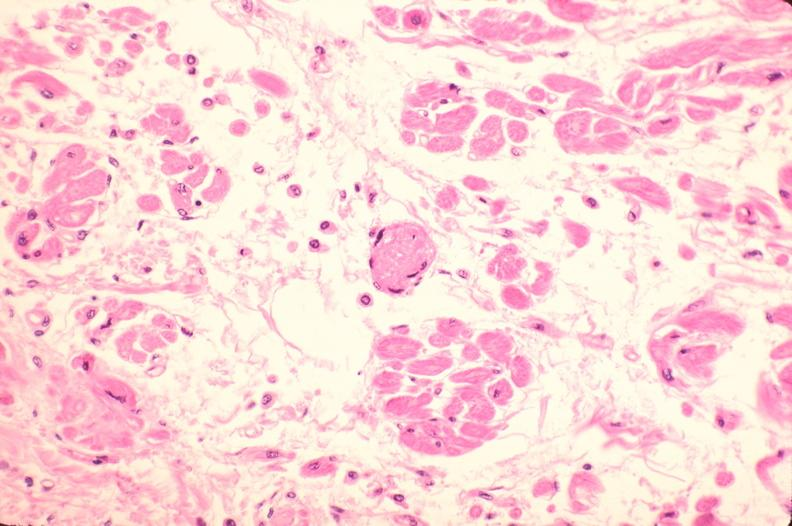does this image show heart, microthrombi, thrombotic thrombocytopenic purpura?
Answer the question using a single word or phrase. Yes 